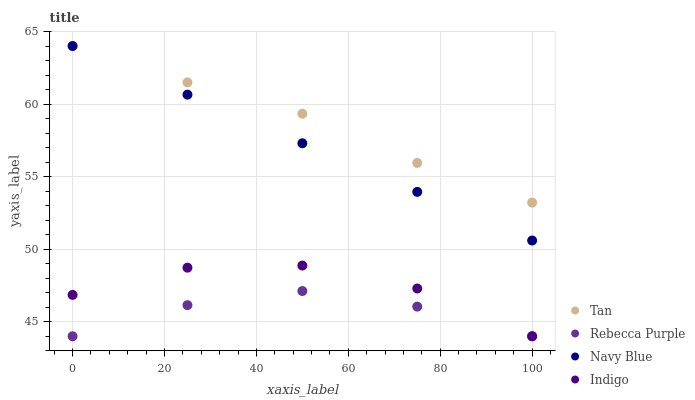Does Rebecca Purple have the minimum area under the curve?
Answer yes or no. Yes. Does Tan have the maximum area under the curve?
Answer yes or no. Yes. Does Indigo have the minimum area under the curve?
Answer yes or no. No. Does Indigo have the maximum area under the curve?
Answer yes or no. No. Is Navy Blue the smoothest?
Answer yes or no. Yes. Is Indigo the roughest?
Answer yes or no. Yes. Is Tan the smoothest?
Answer yes or no. No. Is Tan the roughest?
Answer yes or no. No. Does Indigo have the lowest value?
Answer yes or no. Yes. Does Tan have the lowest value?
Answer yes or no. No. Does Tan have the highest value?
Answer yes or no. Yes. Does Indigo have the highest value?
Answer yes or no. No. Is Indigo less than Tan?
Answer yes or no. Yes. Is Tan greater than Rebecca Purple?
Answer yes or no. Yes. Does Rebecca Purple intersect Indigo?
Answer yes or no. Yes. Is Rebecca Purple less than Indigo?
Answer yes or no. No. Is Rebecca Purple greater than Indigo?
Answer yes or no. No. Does Indigo intersect Tan?
Answer yes or no. No. 